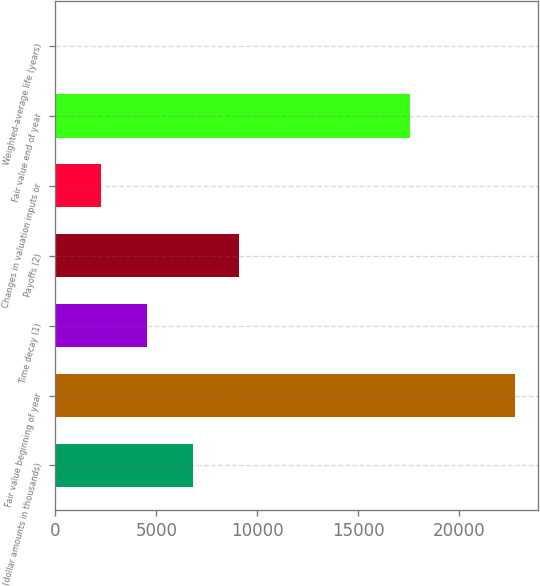<chart> <loc_0><loc_0><loc_500><loc_500><bar_chart><fcel>(dollar amounts in thousands)<fcel>Fair value beginning of year<fcel>Time decay (1)<fcel>Payoffs (2)<fcel>Changes in valuation inputs or<fcel>Fair value end of year<fcel>Weighted-average life (years)<nl><fcel>6839.02<fcel>22786<fcel>4560.88<fcel>9117.16<fcel>2282.74<fcel>17585<fcel>4.6<nl></chart> 